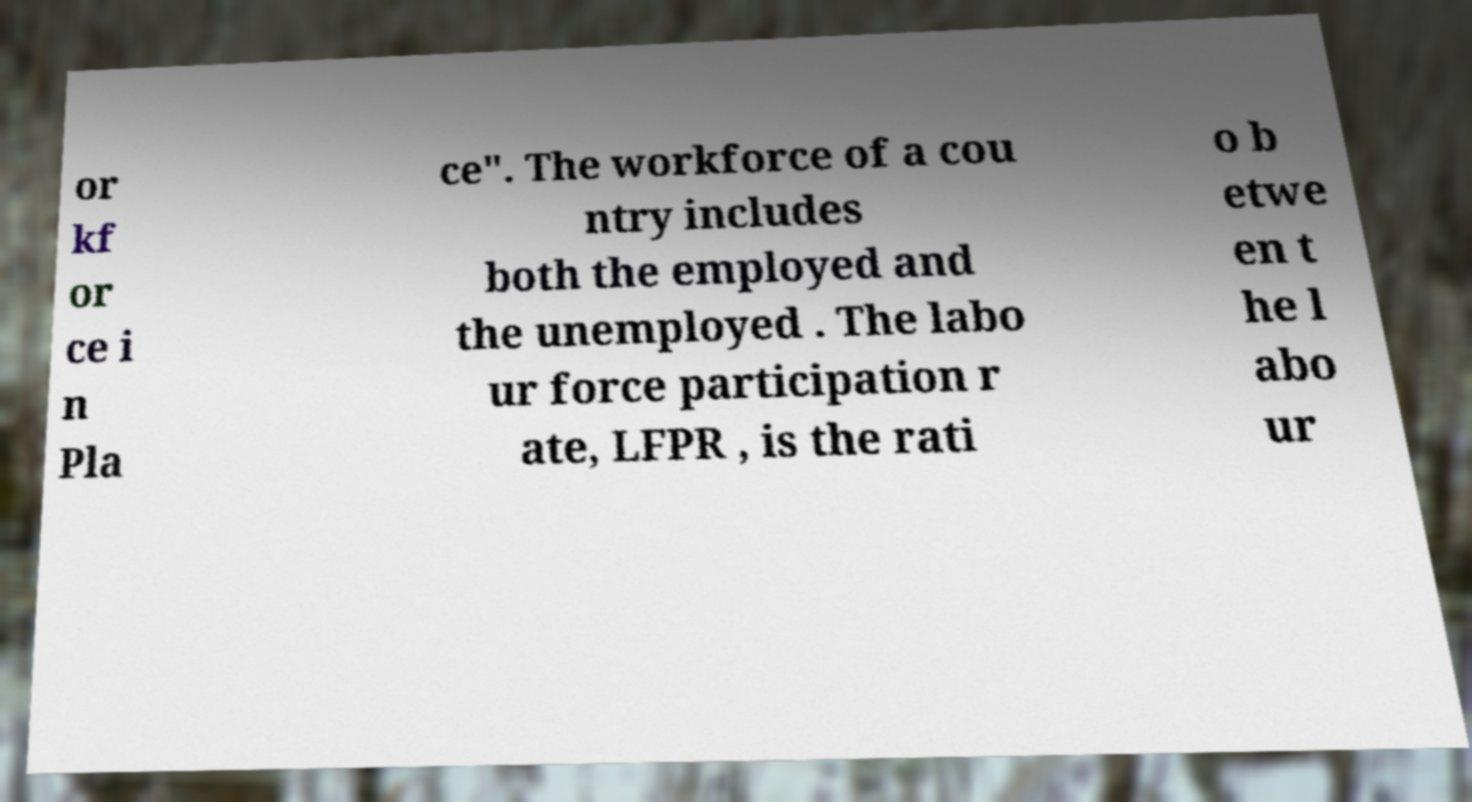There's text embedded in this image that I need extracted. Can you transcribe it verbatim? or kf or ce i n Pla ce". The workforce of a cou ntry includes both the employed and the unemployed . The labo ur force participation r ate, LFPR , is the rati o b etwe en t he l abo ur 